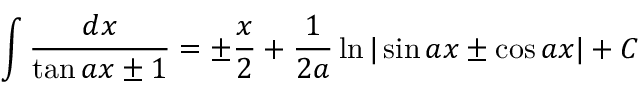<formula> <loc_0><loc_0><loc_500><loc_500>\int { \frac { d x } { \tan a x \pm 1 } } = \pm { \frac { x } { 2 } } + { \frac { 1 } { 2 a } } \ln | \sin a x \pm \cos a x | + C</formula> 